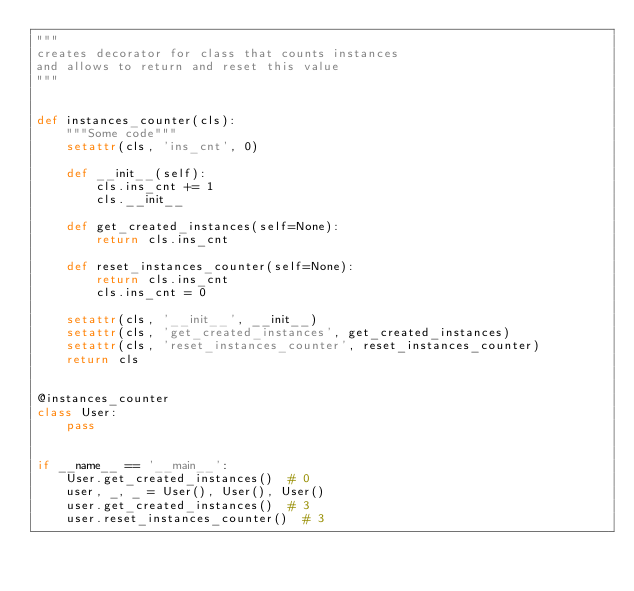<code> <loc_0><loc_0><loc_500><loc_500><_Python_>"""
creates decorator for class that counts instances
and allows to return and reset this value
"""


def instances_counter(cls):
    """Some code"""
    setattr(cls, 'ins_cnt', 0)

    def __init__(self):
        cls.ins_cnt += 1
        cls.__init__

    def get_created_instances(self=None):
        return cls.ins_cnt

    def reset_instances_counter(self=None):
        return cls.ins_cnt
        cls.ins_cnt = 0

    setattr(cls, '__init__', __init__)
    setattr(cls, 'get_created_instances', get_created_instances)
    setattr(cls, 'reset_instances_counter', reset_instances_counter)
    return cls


@instances_counter
class User:
    pass


if __name__ == '__main__':
    User.get_created_instances()  # 0
    user, _, _ = User(), User(), User()
    user.get_created_instances()  # 3
    user.reset_instances_counter()  # 3
</code> 